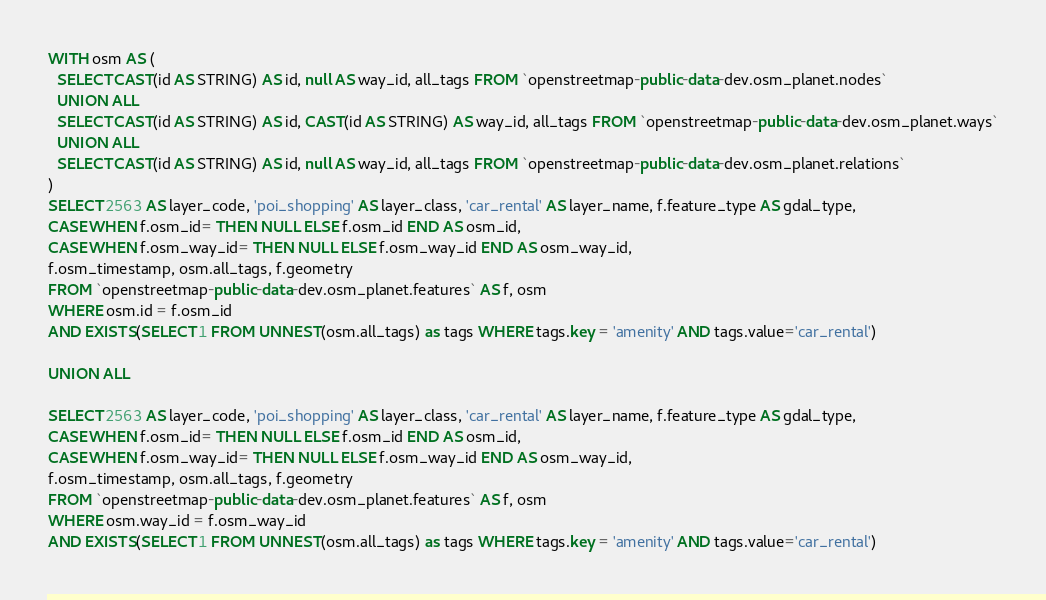Convert code to text. <code><loc_0><loc_0><loc_500><loc_500><_SQL_>
WITH osm AS (
  SELECT CAST(id AS STRING) AS id, null AS way_id, all_tags FROM `openstreetmap-public-data-dev.osm_planet.nodes`
  UNION ALL
  SELECT CAST(id AS STRING) AS id, CAST(id AS STRING) AS way_id, all_tags FROM `openstreetmap-public-data-dev.osm_planet.ways`
  UNION ALL
  SELECT CAST(id AS STRING) AS id, null AS way_id, all_tags FROM `openstreetmap-public-data-dev.osm_planet.relations`
)
SELECT 2563 AS layer_code, 'poi_shopping' AS layer_class, 'car_rental' AS layer_name, f.feature_type AS gdal_type,
CASE WHEN f.osm_id= THEN NULL ELSE f.osm_id END AS osm_id,
CASE WHEN f.osm_way_id= THEN NULL ELSE f.osm_way_id END AS osm_way_id,
f.osm_timestamp, osm.all_tags, f.geometry
FROM `openstreetmap-public-data-dev.osm_planet.features` AS f, osm
WHERE osm.id = f.osm_id
AND EXISTS(SELECT 1 FROM UNNEST(osm.all_tags) as tags WHERE tags.key = 'amenity' AND tags.value='car_rental')

UNION ALL

SELECT 2563 AS layer_code, 'poi_shopping' AS layer_class, 'car_rental' AS layer_name, f.feature_type AS gdal_type,
CASE WHEN f.osm_id= THEN NULL ELSE f.osm_id END AS osm_id,
CASE WHEN f.osm_way_id= THEN NULL ELSE f.osm_way_id END AS osm_way_id,
f.osm_timestamp, osm.all_tags, f.geometry
FROM `openstreetmap-public-data-dev.osm_planet.features` AS f, osm
WHERE osm.way_id = f.osm_way_id
AND EXISTS(SELECT 1 FROM UNNEST(osm.all_tags) as tags WHERE tags.key = 'amenity' AND tags.value='car_rental')

</code> 